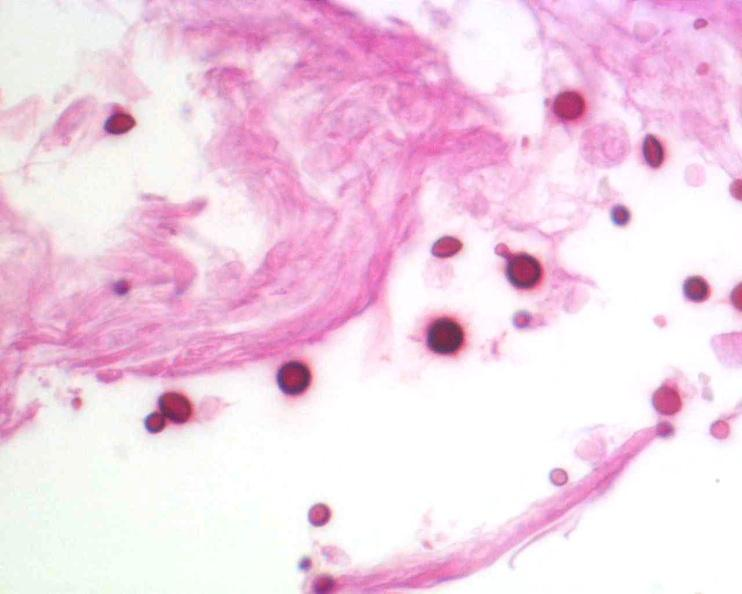what is present?
Answer the question using a single word or phrase. Nervous 